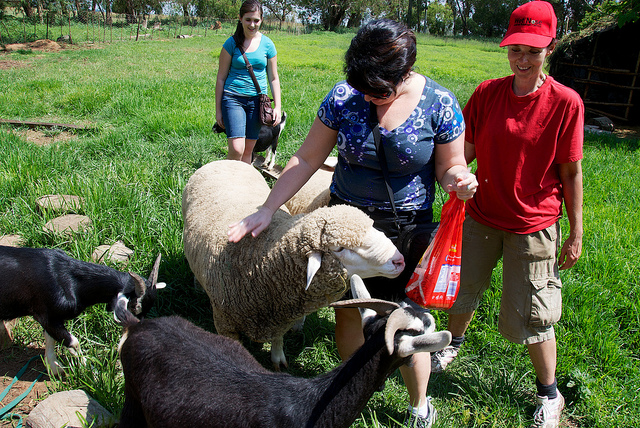Are any of the animals interacting with the people? Yes, one of the sheep is being petted by a woman, and two goats are also nearby, seemingly interacting with the people. The animals appear to be quite comfortable with the human presence. 